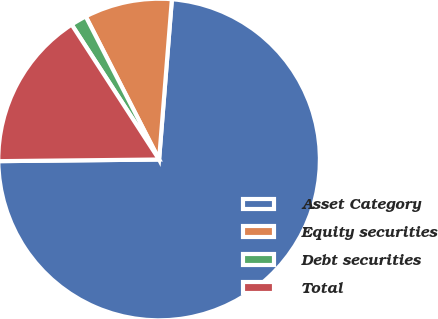Convert chart to OTSL. <chart><loc_0><loc_0><loc_500><loc_500><pie_chart><fcel>Asset Category<fcel>Equity securities<fcel>Debt securities<fcel>Total<nl><fcel>73.57%<fcel>8.81%<fcel>1.61%<fcel>16.01%<nl></chart> 